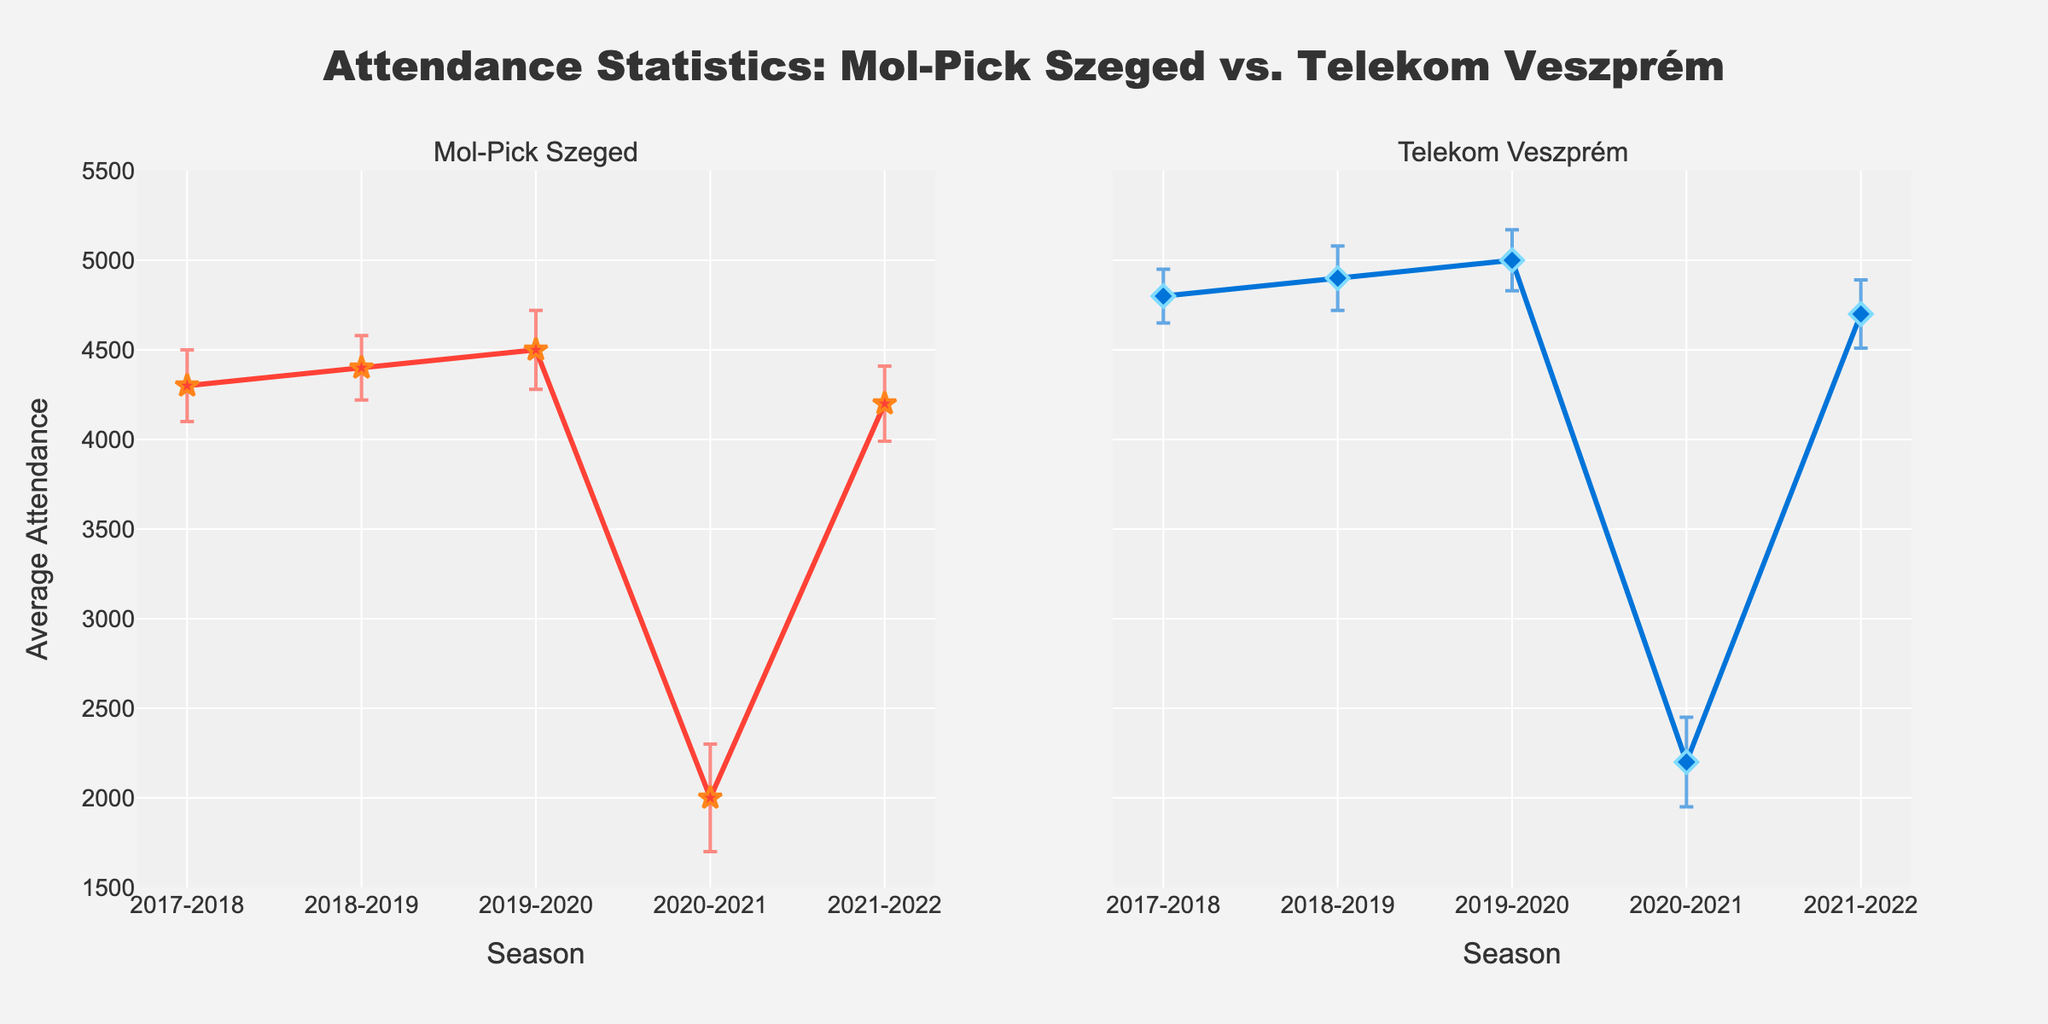What are the titles of the subplots? The subplot titles can be found at the top of each subplot. For Mol-Pick Szeged, the title is "Mol-Pick Szeged," and for Telekom Veszprém, the title is "Telekom Veszprém."
Answer: "Mol-Pick Szeged" and "Telekom Veszprém" Which season had the lowest average attendance for Mol-Pick Szeged? Observing the Mol-Pick Szeged subplot, the lowest average attendance is in the 2020-2021 season, indicated by the lowest point on the line plot.
Answer: 2020-2021 Comparing the 2018-2019 season, which team had a higher average attendance and by how much? For the 2018-2019 season, the average attendance for Mol-Pick Szeged is 4400, and for Telekom Veszprém, it is 4900. Subtract the attendance figures to find the difference: 4900 - 4400 = 500.
Answer: Telekom Veszprém by 500 What is the standard deviation of average attendance for Telekom Veszprém in the 2019-2020 season? Look at the error bars for the 2019-2020 season in the Telekom Veszprém subplot, the value is given as 170 in the provided dataset.
Answer: 170 In which season did both teams show a significant drop in average attendance, and what are the numbers? Both subplots show a significant drop in attendance during the 2020-2021 season. Mol-Pick Szeged had an average of 2000, and Telekom Veszprém had an average of 2200.
Answer: 2020-2021, Mol-Pick Szeged: 2000, Telekom Veszprém: 2200 Which season shows the highest average attendance for Telekom Veszprém? Observing the Telekom Veszprém subplot, the highest point on the plot corresponds to the 2019-2020 season with an average attendance of 5000.
Answer: 2019-2020 What is the range of average attendance for Mol-Pick Szeged across all seasons? The minimum and maximum values for average attendance for Mol-Pick Szeged are 2000 and 4500, respectively. The range is from 2000 to 4500.
Answer: 2000 to 4500 How do the teams' attendance trends compare over the five seasons? Observe the overall trends in both subplots. Mol-Pick Szeged's attendance slightly increased until 2019-2020, dropped significantly in 2020-2021, and started to recover in 2021-2022. Telekom Veszprém's attendance also increased until 2019-2020, had a significant drop in 2020-2021, and partly recovered in the subsequent season.
Answer: Both had an increasing trend until 2019-2020, dropped in 2020-2021, then some recovery Which team had a more consistent (less variability) attendance record during the 2021-2022 season? Compare the length of the error bars in the subplots for the 2021-2022 season. Mol-Pick Szeged's error bar is slightly longer, indicating more variability. Therefore, Telekom Veszprém had a more consistent attendance record.
Answer: Telekom Veszprém 